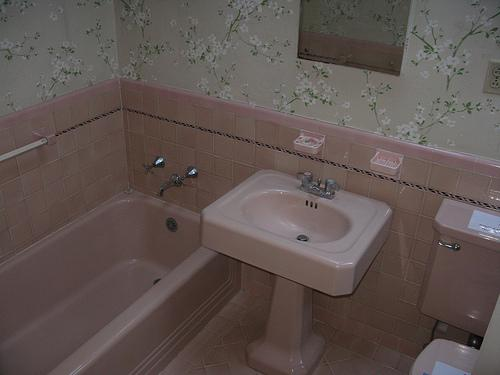How many soap dishes are there in the image and what color are they? There are two pink soap dishes in the image. Identify the color of the bathroom sink and the material of the faucet. The bathroom sink is pink and the faucet is made of silver or chrome. What object is on the wall above the tub and what colors are present on it? A white and pink towel rack is present above the tub. Mention one distinctive feature of the wallpaper in the bathroom. The wallpaper is tan with white flowers. Express the primary emotion or sentiment conveyed by the bathroom interior design. The bathroom has a nostalgic and feminine charm due to the pink fixtures and floral wallpaper. Are there any objects associated with personal hygiene in the image? If yes, mention one. Yes, there is a pink toothbrush holder on the wall. List three objects that are made of metal in the image. Silver faucets on top of the sink, silver toilet handle, and chrome bath tub faucet. What type of handle is on the pink toilet and what is its color? There is a silver toilet handle on the pink toilet. Recognize the activity happening in the bathroom. There is no activity happening in the bathroom as no person is present. Is there any handle in the image? Yes, there is a silver handle on the pink toilet and on the faucets. Detect an event in the image. There is no specific event occurring in the image. Explain if the presence of a wall-mounted vanity mirror implies the existence of a bathroom sink. Yes, the presence of a wall-mounted vanity mirror implies the existence of a bathroom sink as they usually go together in a bathroom setting. Provide a detailed description of the image using an elevated writing style. Behold a pastel pink and white hued bathroom, adorned with a vintage pink sink, toilet, and bathtub; a wall-mounted vanity mirror reflecting ornate floral wallpaper; enchanting chrome faucets and fixtures delicately contributing to the bathroom's charm. Can you find a large window with white curtains on the right side of the bathroom? No, it's not mentioned in the image. What is the color of the drain in the sink? The drain in the sink is not visible. Which of the following bathroom items is white in color? a) toothbrush holder b) sink c) soap dish d) toilet b) sink Design a brief story inspired by the image. Once upon a time, in a quaint little house, there was a charming bathroom like no other. The walls were adorned with floral wallpaper and everything was pastel pink. The bathroom captured the essence of a bygone era, yet provided solace and comfort to every visitor who basked in its warmth. Is the wallpaper covering the entire bathroom wall blue with yellow stripes? The wallpaper is actually tan with white flowers, not blue with yellow stripes. Identify any text present in the image. There is a white sign on top of the toilet tank, but the text is not discernible. Answer this question referring to the image: "What type of wallpaper is in the bathroom?" The wallpaper in the bathroom is tan with white flowers. Describe the design of the towel rack. It is a white and pink towel rack mounted above the bathtub, with a large pole at the top and a bar underneath. Describe the position of the pink toothbrush holder. The pink toothbrush holder is located on the wall above and to the left of the pink sink. Are there purple towels hanging on the towel rack above the tub? There is a towel rack mentioned, but no information about the color of the towels. The assumption of purple towels is misleading. Does the bathroom mirror have a golden frame with intricate patterns? The bathroom mirror is mentioned to have a floral pattern, but there is no information about a golden frame with intricate patterns. What is the color of the toilet seat lid? The toilet seat lid is pink. Explain whether the image can help answer this question: "What is the mechanism of faucets?" The image only shows the external part of the faucets and not their internal mechanism, so it cannot provide a detailed explanation of how faucets work. Identify and describe the main bathroom elements seen in the image. pink handwash, gray metal tap, pink toilet, pink bath tub, silver faucets, pink soap dish, wall mounted vanity mirror Interpret the organization and relationships of elements in the image. The bathroom is organized with the sink, toilet, and bathtub placed against the walls. The faucets and fixtures are attached to the respective elements, while the mirror is mounted above the sink, and the pink toothbrush holder and soap dishes are mounted on the wall near the sink and bathtub. Is there a green rubber duck sitting next to the pink bathtub? There is no mention of a rubber duck in any of the objects listed in the image. 